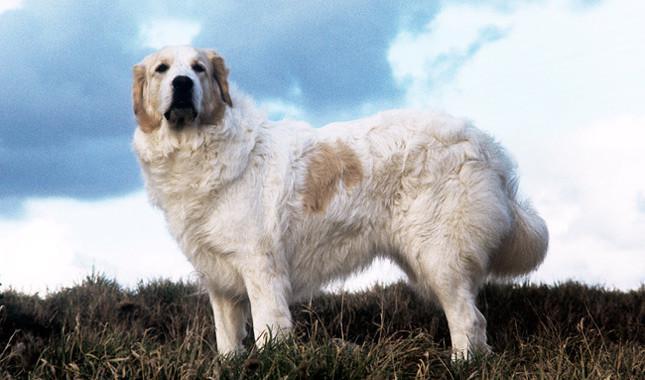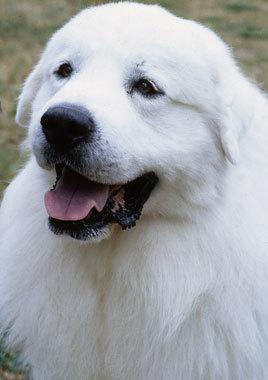The first image is the image on the left, the second image is the image on the right. Evaluate the accuracy of this statement regarding the images: "In at least one image, there is a white dog standing on grass facing left with a back of the sky.". Is it true? Answer yes or no. Yes. The first image is the image on the left, the second image is the image on the right. Examine the images to the left and right. Is the description "There are at least 2 dogs facing left." accurate? Answer yes or no. Yes. The first image is the image on the left, the second image is the image on the right. For the images shown, is this caption "Exactly two white dogs are on their feet, facing the same direction in an outdoor setting, one of them wearing a collar, both of them open mouthed with tongues showing." true? Answer yes or no. No. The first image is the image on the left, the second image is the image on the right. Examine the images to the left and right. Is the description "Each image contains a large white dog standing still with its body in profile, and the dogs in the images face the same direction." accurate? Answer yes or no. No. 